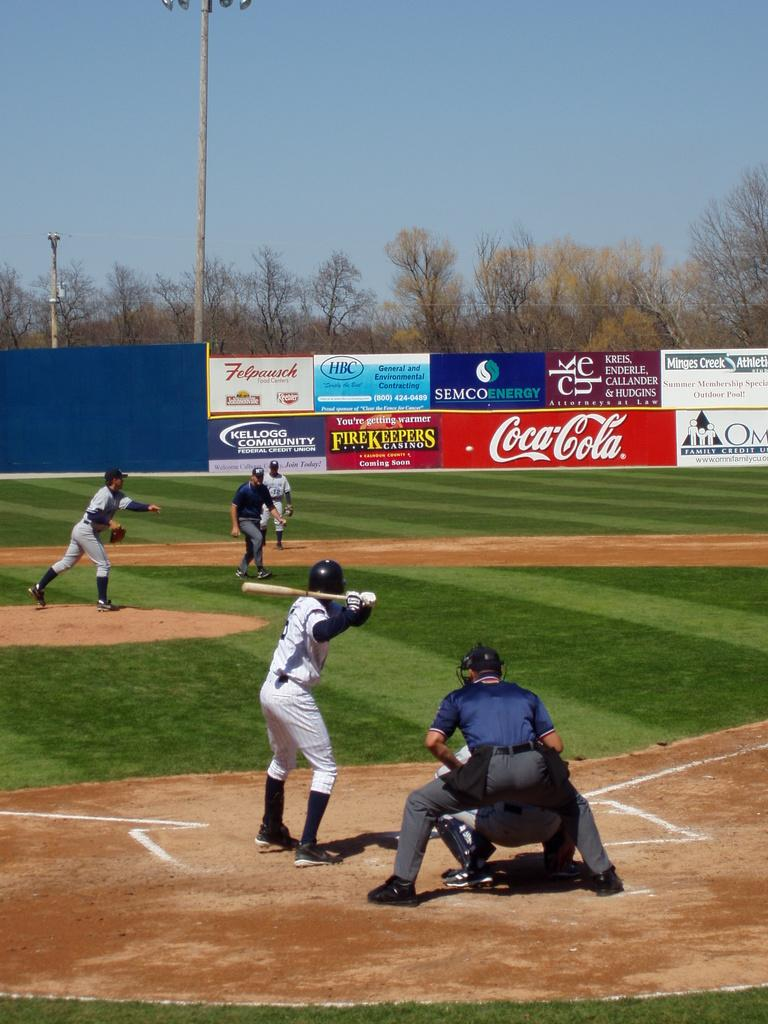<image>
Describe the image concisely. Men playing baseball with a coca cola ad on the field 